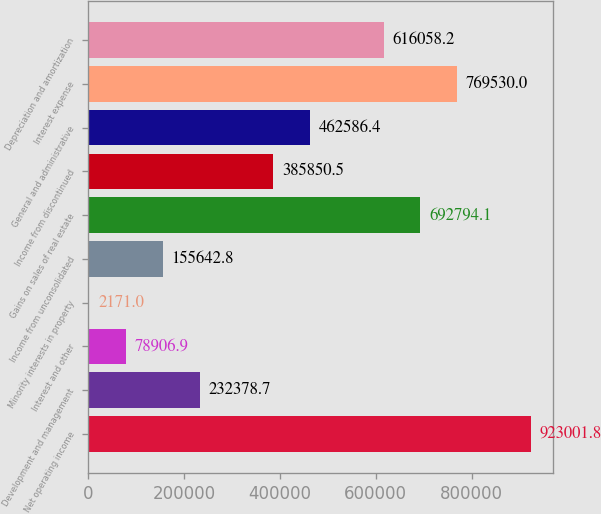Convert chart. <chart><loc_0><loc_0><loc_500><loc_500><bar_chart><fcel>Net operating income<fcel>Development and management<fcel>Interest and other<fcel>Minority interests in property<fcel>Income from unconsolidated<fcel>Gains on sales of real estate<fcel>Income from discontinued<fcel>General and administrative<fcel>Interest expense<fcel>Depreciation and amortization<nl><fcel>923002<fcel>232379<fcel>78906.9<fcel>2171<fcel>155643<fcel>692794<fcel>385850<fcel>462586<fcel>769530<fcel>616058<nl></chart> 